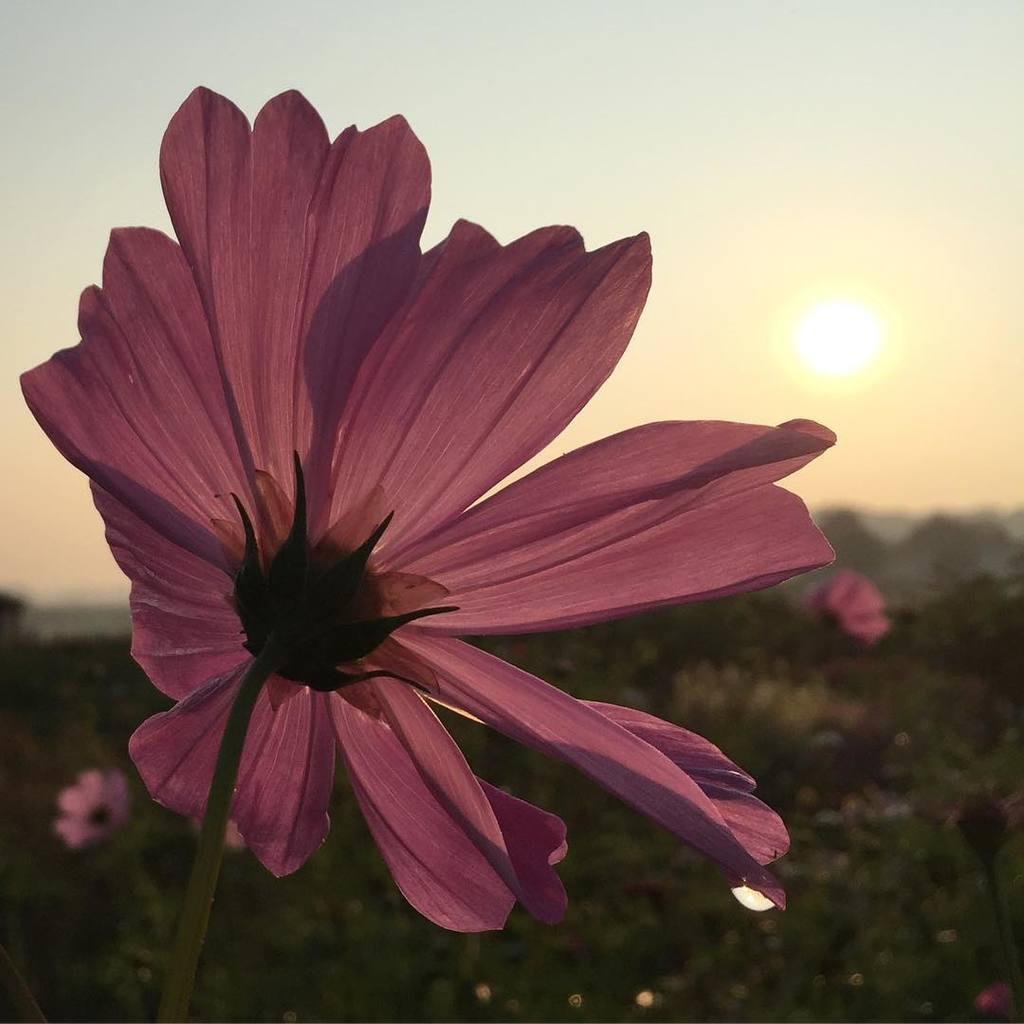In one or two sentences, can you explain what this image depicts? In this image we can see some flowers, plants, trees and mountains, in the background, we can see the sunset and the sky. 